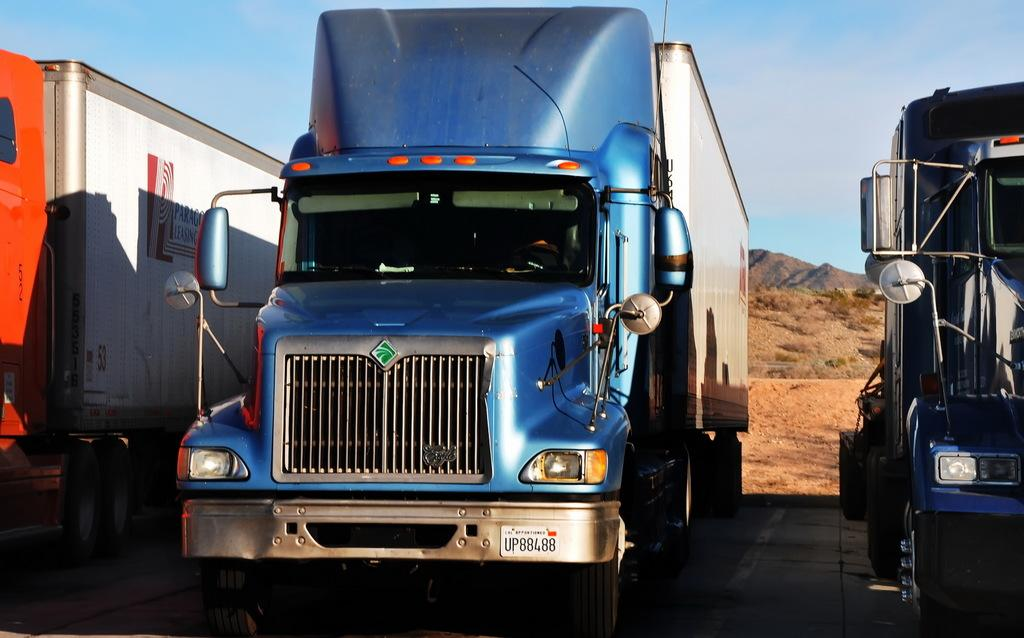What type of vehicles are on the ground in the image? There are trucks on the ground in the image. What else can be seen in the image besides the trucks? Plants and hills are visible in the image. What is visible in the background of the image? The sky is visible in the image. How would you describe the sky in the image? The sky appears cloudy in the image. What channel is the pleasure being broadcasted on in the image? There is no channel or broadcasting of pleasure present in the image. 